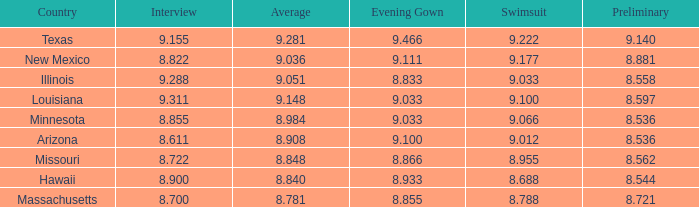I'm looking to parse the entire table for insights. Could you assist me with that? {'header': ['Country', 'Interview', 'Average', 'Evening Gown', 'Swimsuit', 'Preliminary'], 'rows': [['Texas', '9.155', '9.281', '9.466', '9.222', '9.140'], ['New Mexico', '8.822', '9.036', '9.111', '9.177', '8.881'], ['Illinois', '9.288', '9.051', '8.833', '9.033', '8.558'], ['Louisiana', '9.311', '9.148', '9.033', '9.100', '8.597'], ['Minnesota', '8.855', '8.984', '9.033', '9.066', '8.536'], ['Arizona', '8.611', '8.908', '9.100', '9.012', '8.536'], ['Missouri', '8.722', '8.848', '8.866', '8.955', '8.562'], ['Hawaii', '8.900', '8.840', '8.933', '8.688', '8.544'], ['Massachusetts', '8.700', '8.781', '8.855', '8.788', '8.721']]} What was the swimsuit score for Illinois? 9.033. 